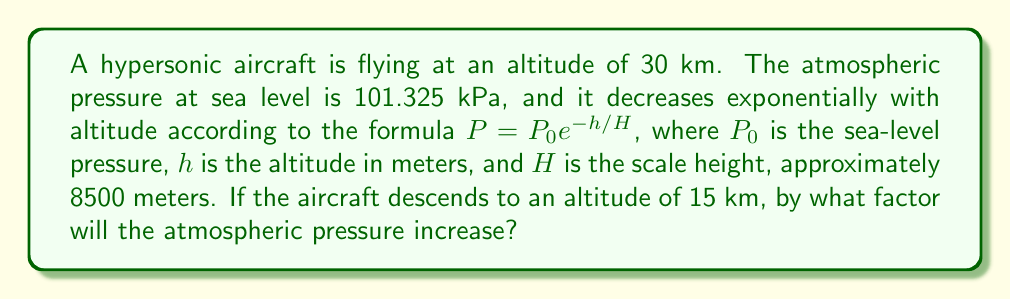Solve this math problem. To solve this problem, we need to follow these steps:

1) First, let's calculate the pressure at 30 km altitude:
   $$P_{30} = 101.325 \cdot e^{-30000/8500} \approx 1.197 \text{ kPa}$$

2) Now, let's calculate the pressure at 15 km altitude:
   $$P_{15} = 101.325 \cdot e^{-15000/8500} \approx 12.111 \text{ kPa}$$

3) To find the factor by which the pressure increases, we divide the pressure at 15 km by the pressure at 30 km:

   $$\text{Factor} = \frac{P_{15}}{P_{30}} = \frac{12.111}{1.197} \approx 10.12$$

4) We can verify this result using the properties of exponents:

   $$\frac{P_{15}}{P_{30}} = \frac{P_0 e^{-15000/8500}}{P_0 e^{-30000/8500}} = e^{(30000-15000)/8500} = e^{15000/8500} \approx 10.12$$

This shows that the pressure increases by a factor of approximately 10.12 when the aircraft descends from 30 km to 15 km.
Answer: The atmospheric pressure will increase by a factor of approximately 10.12. 